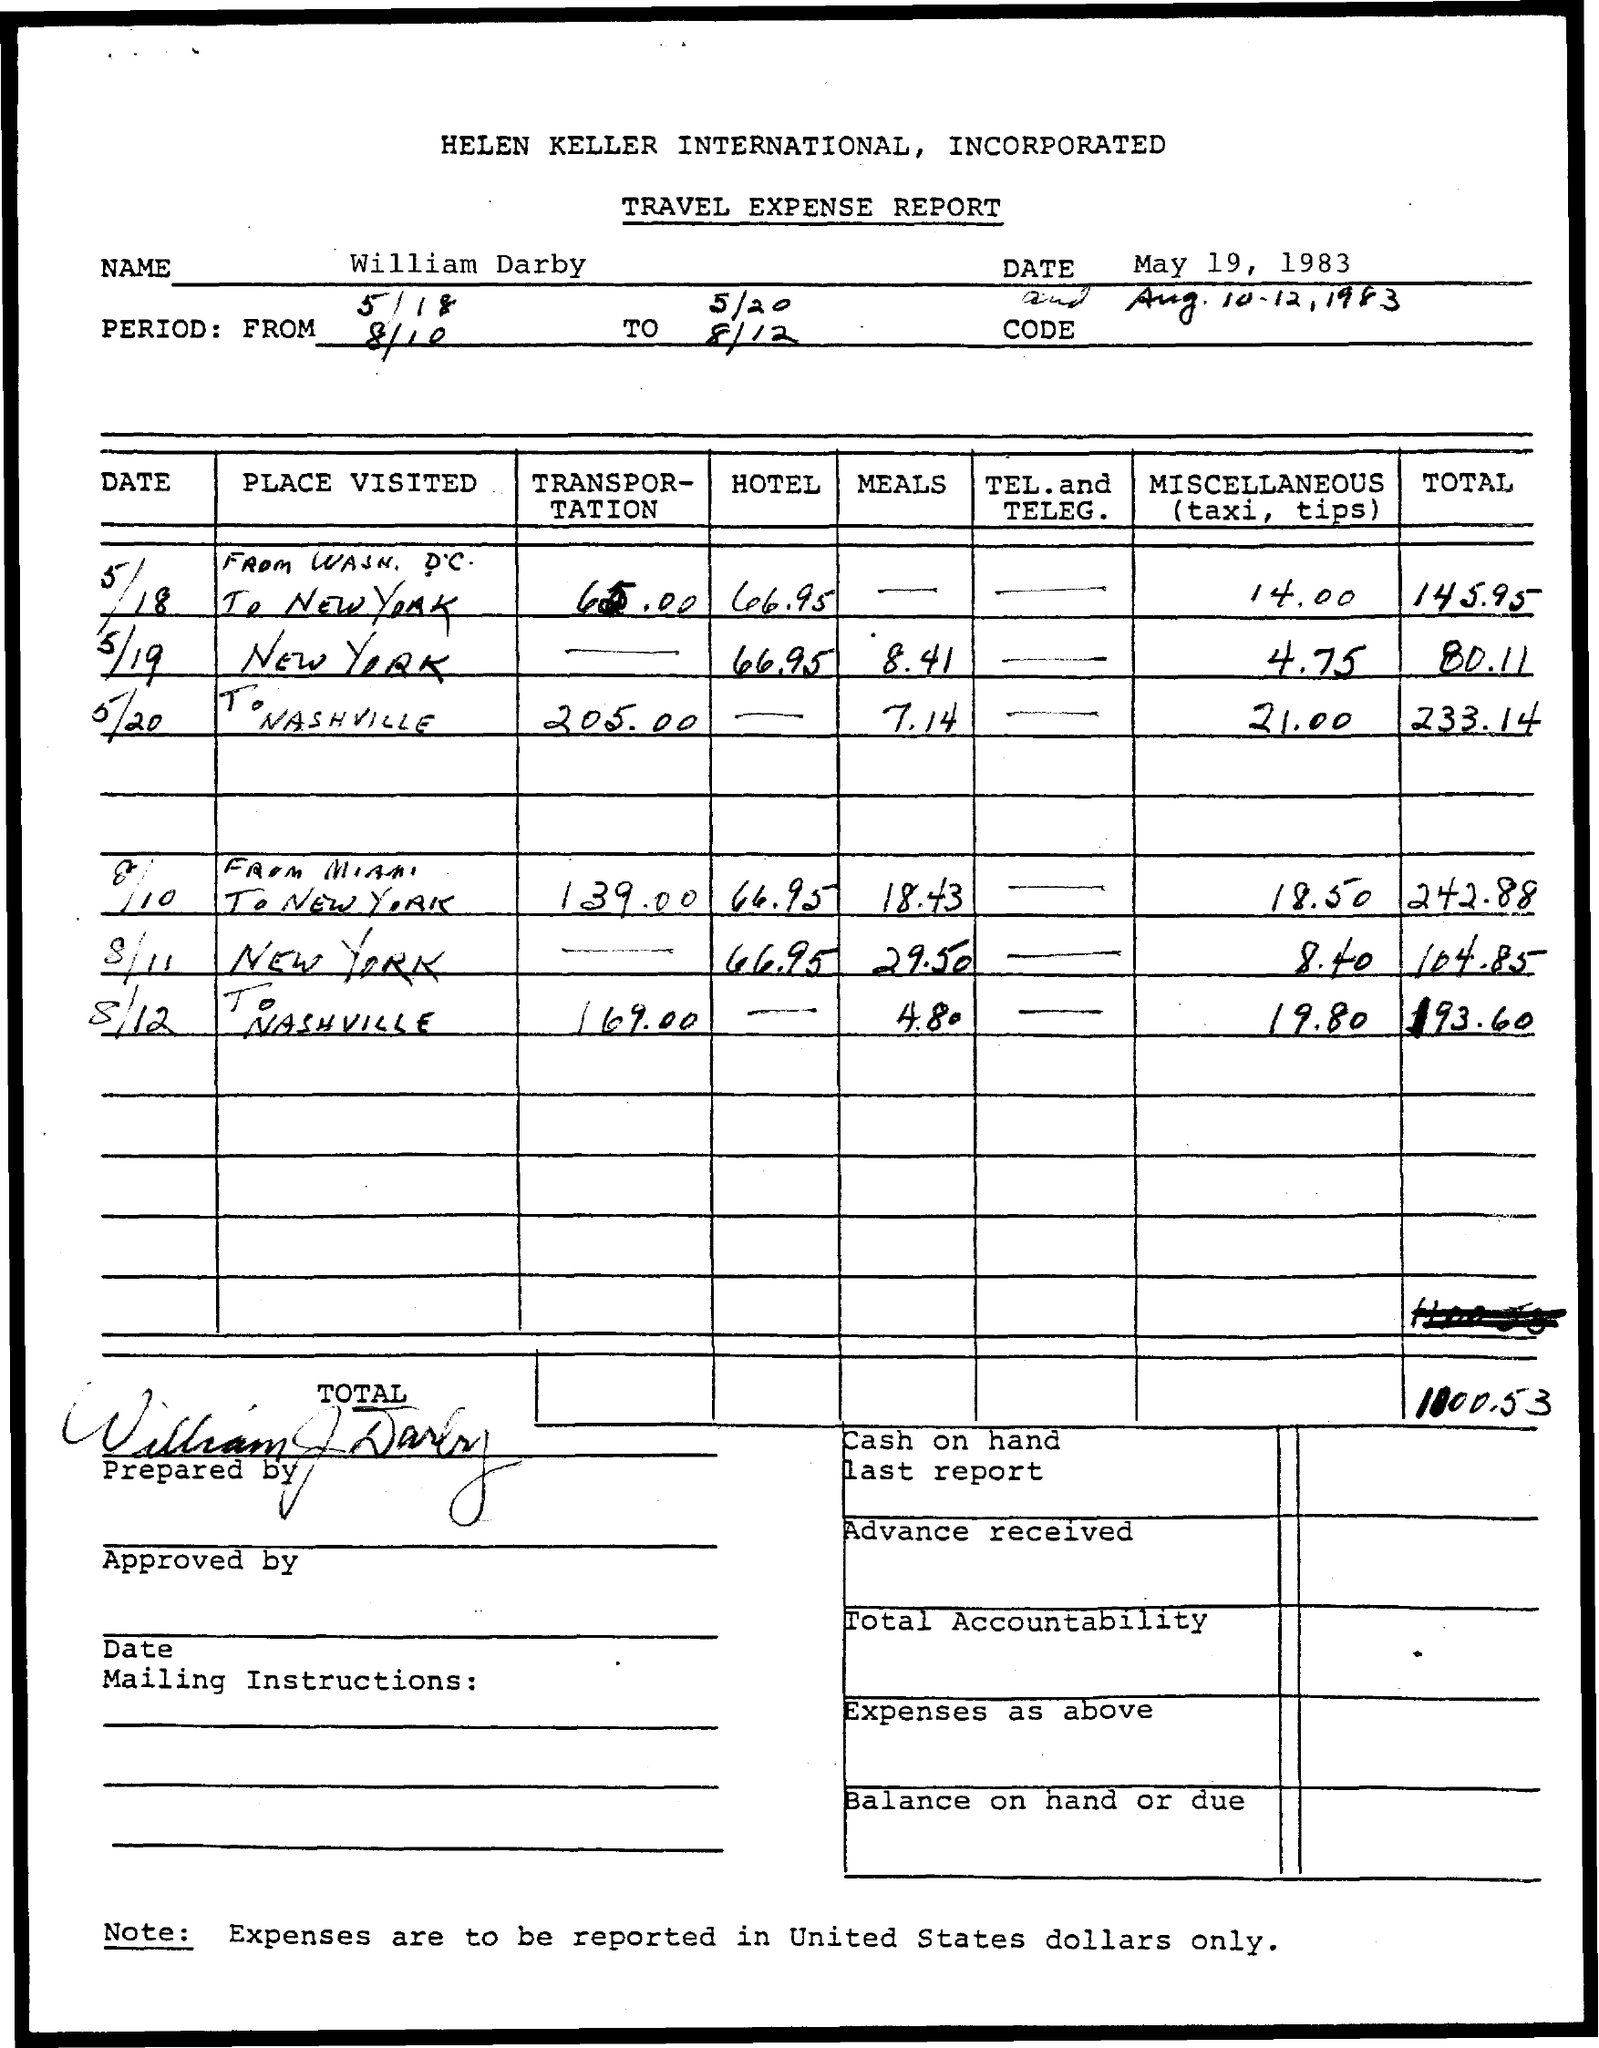What is the name of the person mentioned in the document?
Your response must be concise. William Darby. 